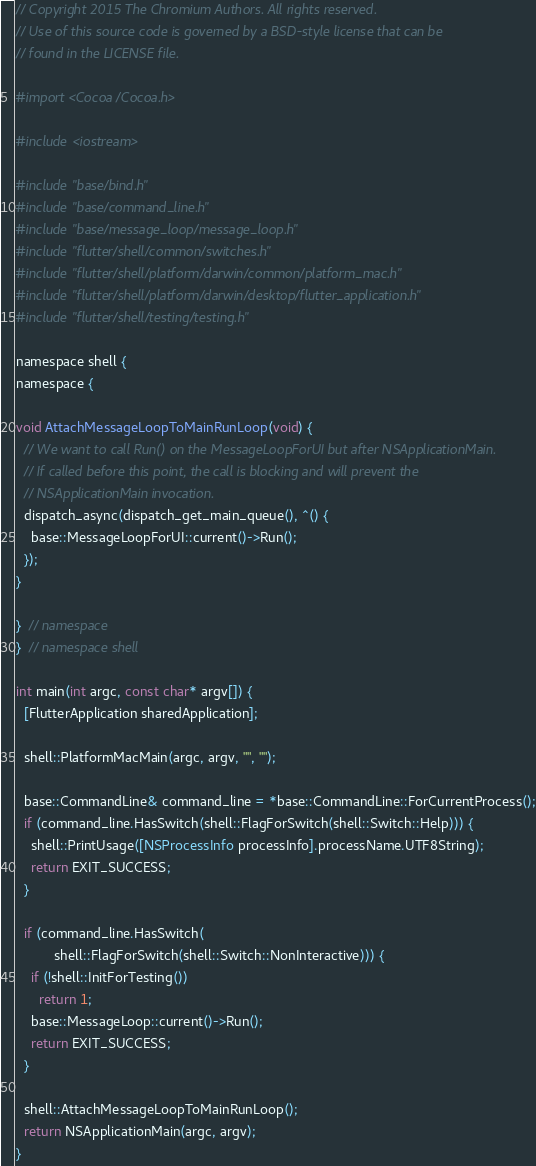<code> <loc_0><loc_0><loc_500><loc_500><_ObjectiveC_>// Copyright 2015 The Chromium Authors. All rights reserved.
// Use of this source code is governed by a BSD-style license that can be
// found in the LICENSE file.

#import <Cocoa/Cocoa.h>

#include <iostream>

#include "base/bind.h"
#include "base/command_line.h"
#include "base/message_loop/message_loop.h"
#include "flutter/shell/common/switches.h"
#include "flutter/shell/platform/darwin/common/platform_mac.h"
#include "flutter/shell/platform/darwin/desktop/flutter_application.h"
#include "flutter/shell/testing/testing.h"

namespace shell {
namespace {

void AttachMessageLoopToMainRunLoop(void) {
  // We want to call Run() on the MessageLoopForUI but after NSApplicationMain.
  // If called before this point, the call is blocking and will prevent the
  // NSApplicationMain invocation.
  dispatch_async(dispatch_get_main_queue(), ^() {
    base::MessageLoopForUI::current()->Run();
  });
}

}  // namespace
}  // namespace shell

int main(int argc, const char* argv[]) {
  [FlutterApplication sharedApplication];

  shell::PlatformMacMain(argc, argv, "", "");

  base::CommandLine& command_line = *base::CommandLine::ForCurrentProcess();
  if (command_line.HasSwitch(shell::FlagForSwitch(shell::Switch::Help))) {
    shell::PrintUsage([NSProcessInfo processInfo].processName.UTF8String);
    return EXIT_SUCCESS;
  }

  if (command_line.HasSwitch(
          shell::FlagForSwitch(shell::Switch::NonInteractive))) {
    if (!shell::InitForTesting())
      return 1;
    base::MessageLoop::current()->Run();
    return EXIT_SUCCESS;
  }

  shell::AttachMessageLoopToMainRunLoop();
  return NSApplicationMain(argc, argv);
}
</code> 